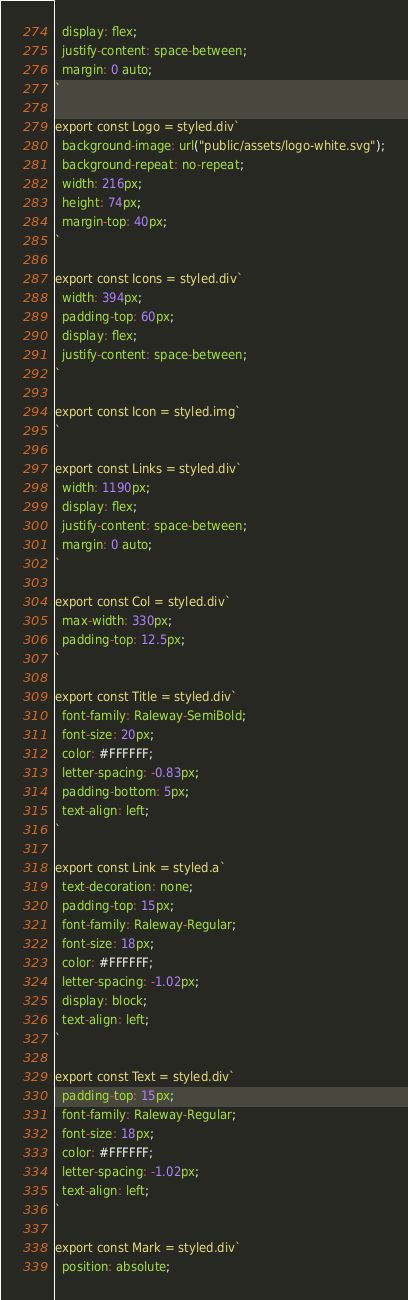Convert code to text. <code><loc_0><loc_0><loc_500><loc_500><_JavaScript_>  display: flex;
  justify-content: space-between;
  margin: 0 auto;
`

export const Logo = styled.div`
  background-image: url("public/assets/logo-white.svg");
  background-repeat: no-repeat;
  width: 216px;
  height: 74px;
  margin-top: 40px;
`

export const Icons = styled.div`
  width: 394px;
  padding-top: 60px;
  display: flex;
  justify-content: space-between;
`

export const Icon = styled.img`
`

export const Links = styled.div`
  width: 1190px;
  display: flex;
  justify-content: space-between;
  margin: 0 auto;
`

export const Col = styled.div`
  max-width: 330px;
  padding-top: 12.5px;
`

export const Title = styled.div`
  font-family: Raleway-SemiBold;
  font-size: 20px;
  color: #FFFFFF;
  letter-spacing: -0.83px;
  padding-bottom: 5px;
  text-align: left;
`

export const Link = styled.a`
  text-decoration: none;
  padding-top: 15px;
  font-family: Raleway-Regular;
  font-size: 18px;
  color: #FFFFFF;
  letter-spacing: -1.02px;
  display: block;
  text-align: left;
`

export const Text = styled.div`
  padding-top: 15px;
  font-family: Raleway-Regular;
  font-size: 18px;
  color: #FFFFFF;
  letter-spacing: -1.02px;
  text-align: left;
`

export const Mark = styled.div`
  position: absolute;</code> 